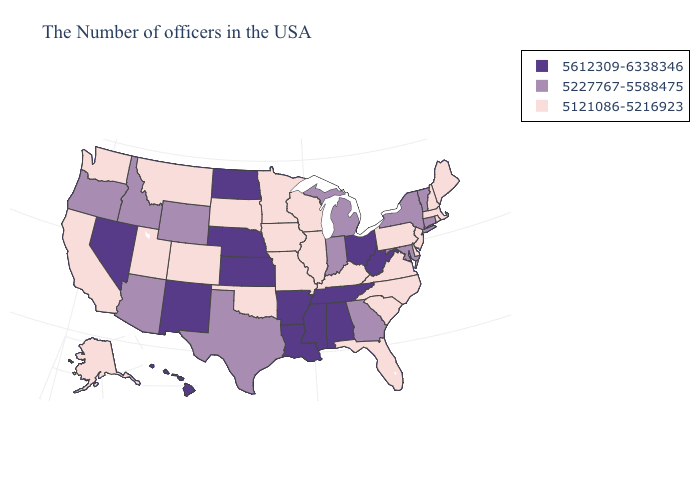Name the states that have a value in the range 5612309-6338346?
Answer briefly. West Virginia, Ohio, Alabama, Tennessee, Mississippi, Louisiana, Arkansas, Kansas, Nebraska, North Dakota, New Mexico, Nevada, Hawaii. What is the lowest value in states that border New Hampshire?
Keep it brief. 5121086-5216923. Name the states that have a value in the range 5227767-5588475?
Concise answer only. Vermont, Connecticut, New York, Maryland, Georgia, Michigan, Indiana, Texas, Wyoming, Arizona, Idaho, Oregon. Does North Carolina have a lower value than Oklahoma?
Short answer required. No. Does New York have the lowest value in the USA?
Short answer required. No. Name the states that have a value in the range 5227767-5588475?
Answer briefly. Vermont, Connecticut, New York, Maryland, Georgia, Michigan, Indiana, Texas, Wyoming, Arizona, Idaho, Oregon. What is the value of New Hampshire?
Concise answer only. 5121086-5216923. Name the states that have a value in the range 5227767-5588475?
Concise answer only. Vermont, Connecticut, New York, Maryland, Georgia, Michigan, Indiana, Texas, Wyoming, Arizona, Idaho, Oregon. Name the states that have a value in the range 5612309-6338346?
Keep it brief. West Virginia, Ohio, Alabama, Tennessee, Mississippi, Louisiana, Arkansas, Kansas, Nebraska, North Dakota, New Mexico, Nevada, Hawaii. How many symbols are there in the legend?
Concise answer only. 3. Name the states that have a value in the range 5121086-5216923?
Keep it brief. Maine, Massachusetts, Rhode Island, New Hampshire, New Jersey, Delaware, Pennsylvania, Virginia, North Carolina, South Carolina, Florida, Kentucky, Wisconsin, Illinois, Missouri, Minnesota, Iowa, Oklahoma, South Dakota, Colorado, Utah, Montana, California, Washington, Alaska. Name the states that have a value in the range 5612309-6338346?
Be succinct. West Virginia, Ohio, Alabama, Tennessee, Mississippi, Louisiana, Arkansas, Kansas, Nebraska, North Dakota, New Mexico, Nevada, Hawaii. Does Alaska have the lowest value in the West?
Write a very short answer. Yes. Does Minnesota have the highest value in the USA?
Short answer required. No. Name the states that have a value in the range 5227767-5588475?
Answer briefly. Vermont, Connecticut, New York, Maryland, Georgia, Michigan, Indiana, Texas, Wyoming, Arizona, Idaho, Oregon. 